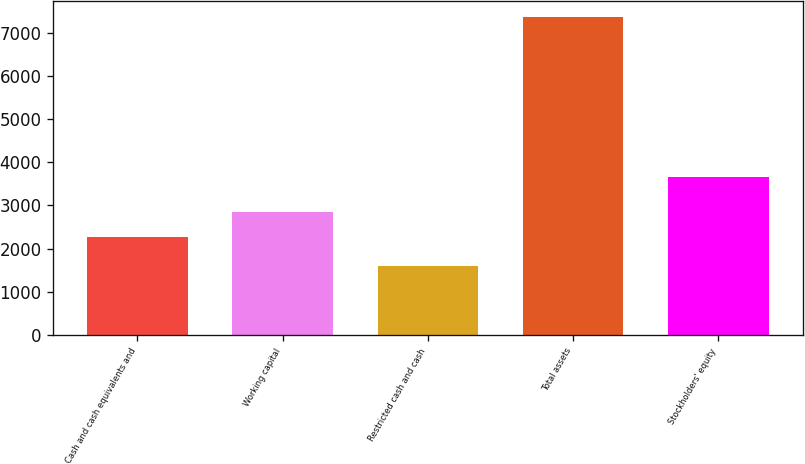<chart> <loc_0><loc_0><loc_500><loc_500><bar_chart><fcel>Cash and cash equivalents and<fcel>Working capital<fcel>Restricted cash and cash<fcel>Total assets<fcel>Stockholders' equity<nl><fcel>2262<fcel>2838.3<fcel>1606<fcel>7369<fcel>3648<nl></chart> 